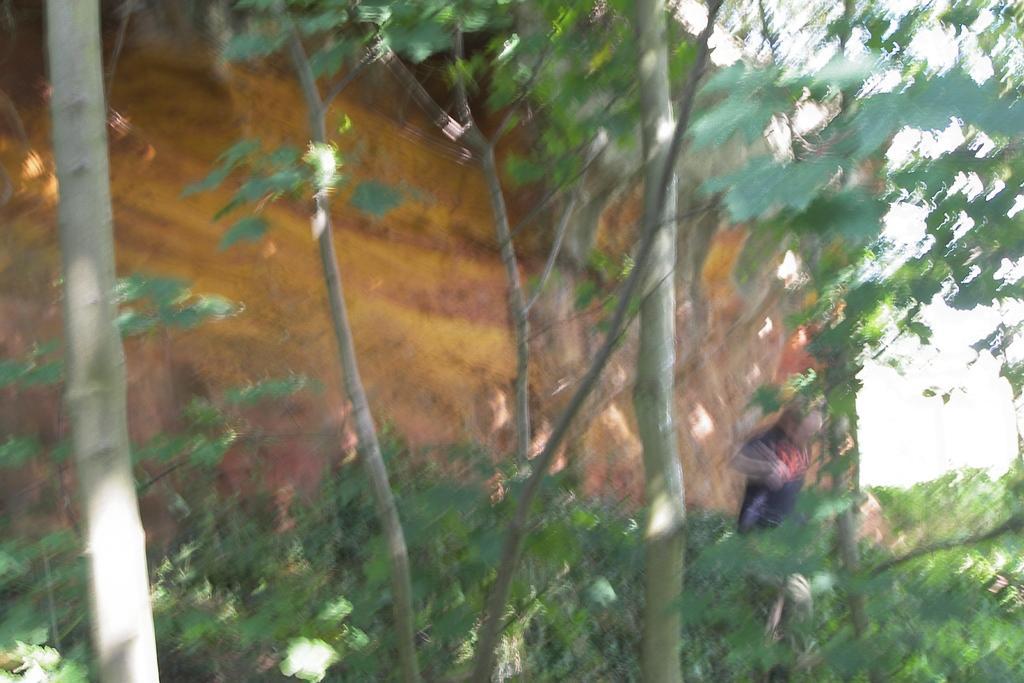Please provide a concise description of this image. In the foreground of the image we can see a group of trees, plants, a person standing on the ground. In the background, we can see mountains and the sky. 